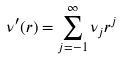<formula> <loc_0><loc_0><loc_500><loc_500>\nu ^ { \prime } ( r ) = \sum _ { j = - 1 } ^ { \infty } \nu _ { j } r ^ { j }</formula> 